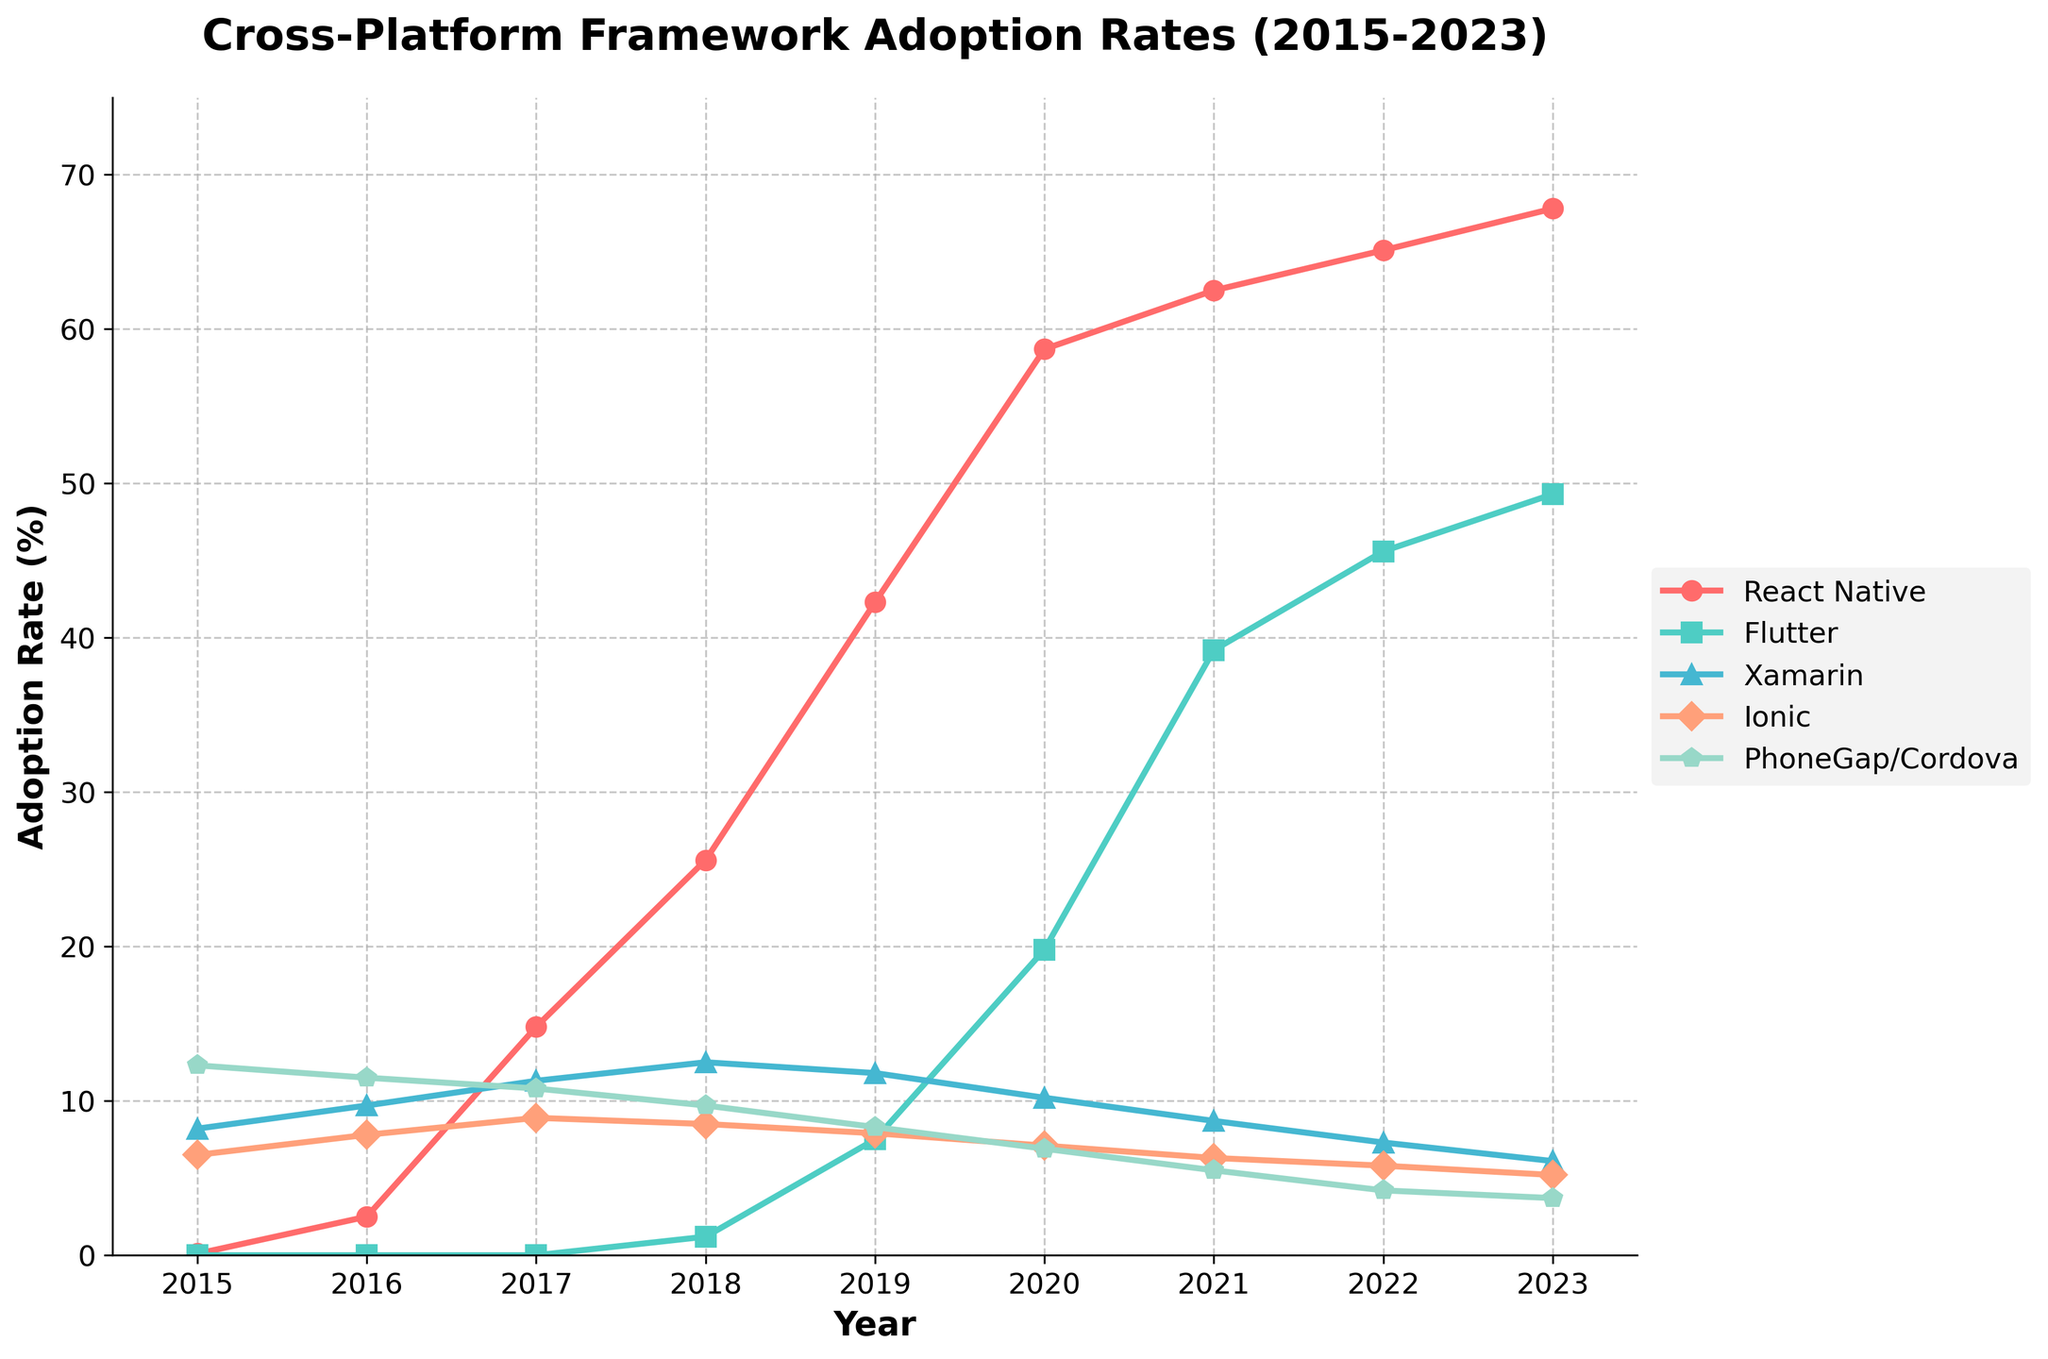Which framework had the highest adoption rate in 2023? The figure shows the lines representing different frameworks. The one with the highest adoption rate in 2023 is indicated by the tallest point on the y-axis for that year.
Answer: React Native What is the overall trend of Flutter’s adoption rate from 2015 to 2023? By observing the trajectory of Flutter’s line, you can see that it starts at 0% in 2015 and steadily increases to 49.3% in 2023.
Answer: Increasing Which year did React Native surpass 50% adoption rate? Find the point where the React Native line exceeds the 50% mark on the y-axis. This happens between 2019 and 2020.
Answer: 2020 By how much did the adoption rate of Ionic decrease from 2017 to 2023? Locate Ionic’s adoption rate in both 2017 and 2023, then subtract the 2023 value from the 2017 value: 8.9% - 5.2% = 3.7%.
Answer: 3.7% Which two frameworks had the closest adoption rates in 2018? By examining the points for each framework in 2018, identify the two frameworks with the smallest numerical difference in their adoption rates.
Answer: Ionic and Xamarin What was the aggregate adoption rate of React Native and Flutter in 2023? Add the adoption rates of React Native and Flutter for the year 2023: 67.8% + 49.3% = 117.1%.
Answer: 117.1% Compare the adoption rate of PhoneGap/Cordova in 2015 and 2023. Was it higher or lower in 2023? Check the adoption rates for PhoneGap/Cordova in both years. Since 12.3% in 2015 is greater than 3.7% in 2023, it is lower in 2023.
Answer: Lower Which framework had a drop in adoption rate between 2019 and 2020? Identify the framework by looking at the slopes of each line; the one that shows a downward trend between these years is Xamarin.
Answer: Xamarin 